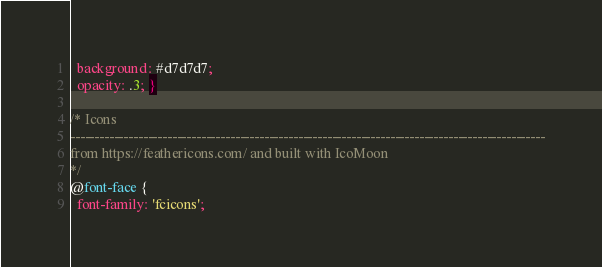Convert code to text. <code><loc_0><loc_0><loc_500><loc_500><_CSS_>  background: #d7d7d7;
  opacity: .3; }

/* Icons
--------------------------------------------------------------------------------------------------
from https://feathericons.com/ and built with IcoMoon
*/
@font-face {
  font-family: 'fcicons';</code> 